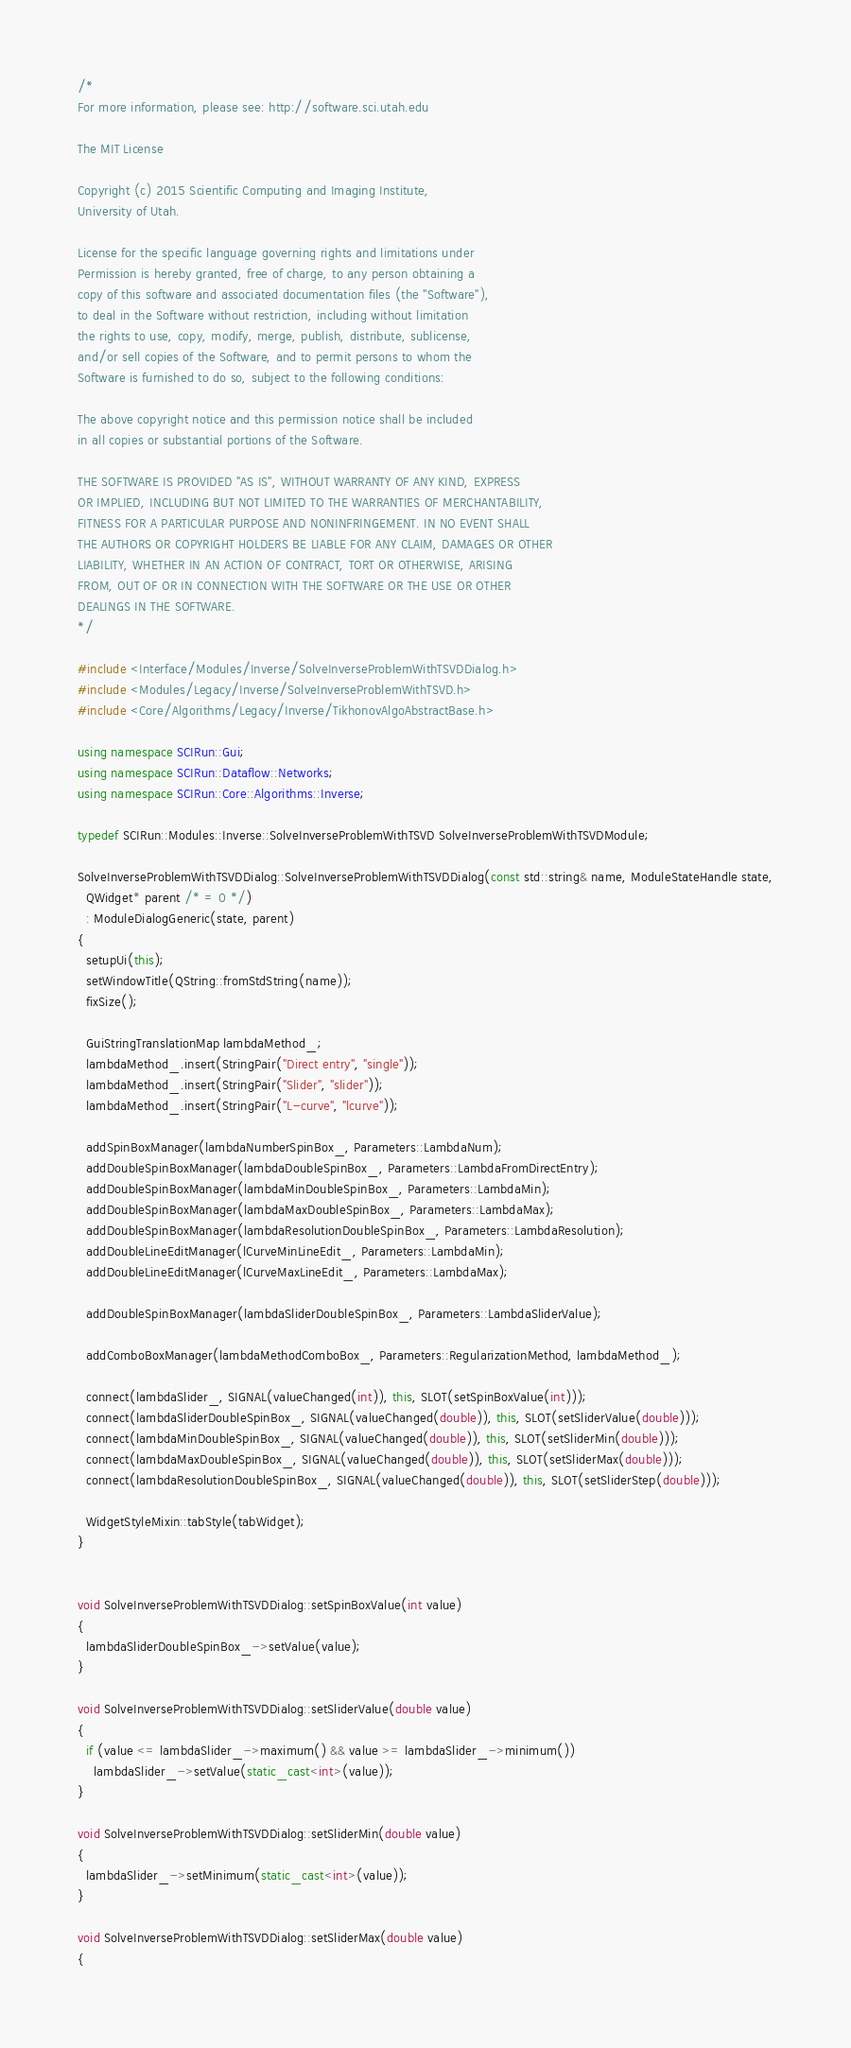<code> <loc_0><loc_0><loc_500><loc_500><_C++_>/*
For more information, please see: http://software.sci.utah.edu

The MIT License

Copyright (c) 2015 Scientific Computing and Imaging Institute,
University of Utah.

License for the specific language governing rights and limitations under
Permission is hereby granted, free of charge, to any person obtaining a
copy of this software and associated documentation files (the "Software"),
to deal in the Software without restriction, including without limitation
the rights to use, copy, modify, merge, publish, distribute, sublicense,
and/or sell copies of the Software, and to permit persons to whom the
Software is furnished to do so, subject to the following conditions:

The above copyright notice and this permission notice shall be included
in all copies or substantial portions of the Software.

THE SOFTWARE IS PROVIDED "AS IS", WITHOUT WARRANTY OF ANY KIND, EXPRESS
OR IMPLIED, INCLUDING BUT NOT LIMITED TO THE WARRANTIES OF MERCHANTABILITY,
FITNESS FOR A PARTICULAR PURPOSE AND NONINFRINGEMENT. IN NO EVENT SHALL
THE AUTHORS OR COPYRIGHT HOLDERS BE LIABLE FOR ANY CLAIM, DAMAGES OR OTHER
LIABILITY, WHETHER IN AN ACTION OF CONTRACT, TORT OR OTHERWISE, ARISING
FROM, OUT OF OR IN CONNECTION WITH THE SOFTWARE OR THE USE OR OTHER
DEALINGS IN THE SOFTWARE.
*/

#include <Interface/Modules/Inverse/SolveInverseProblemWithTSVDDialog.h>
#include <Modules/Legacy/Inverse/SolveInverseProblemWithTSVD.h>
#include <Core/Algorithms/Legacy/Inverse/TikhonovAlgoAbstractBase.h>

using namespace SCIRun::Gui;
using namespace SCIRun::Dataflow::Networks;
using namespace SCIRun::Core::Algorithms::Inverse;

typedef SCIRun::Modules::Inverse::SolveInverseProblemWithTSVD SolveInverseProblemWithTSVDModule;

SolveInverseProblemWithTSVDDialog::SolveInverseProblemWithTSVDDialog(const std::string& name, ModuleStateHandle state,
  QWidget* parent /* = 0 */)
  : ModuleDialogGeneric(state, parent)
{
  setupUi(this);
  setWindowTitle(QString::fromStdString(name));
  fixSize();

  GuiStringTranslationMap lambdaMethod_;
  lambdaMethod_.insert(StringPair("Direct entry", "single"));
  lambdaMethod_.insert(StringPair("Slider", "slider"));
  lambdaMethod_.insert(StringPair("L-curve", "lcurve"));

  addSpinBoxManager(lambdaNumberSpinBox_, Parameters::LambdaNum);
  addDoubleSpinBoxManager(lambdaDoubleSpinBox_, Parameters::LambdaFromDirectEntry);
  addDoubleSpinBoxManager(lambdaMinDoubleSpinBox_, Parameters::LambdaMin);
  addDoubleSpinBoxManager(lambdaMaxDoubleSpinBox_, Parameters::LambdaMax);
  addDoubleSpinBoxManager(lambdaResolutionDoubleSpinBox_, Parameters::LambdaResolution);
  addDoubleLineEditManager(lCurveMinLineEdit_, Parameters::LambdaMin);
  addDoubleLineEditManager(lCurveMaxLineEdit_, Parameters::LambdaMax);

  addDoubleSpinBoxManager(lambdaSliderDoubleSpinBox_, Parameters::LambdaSliderValue);

  addComboBoxManager(lambdaMethodComboBox_, Parameters::RegularizationMethod, lambdaMethod_);

  connect(lambdaSlider_, SIGNAL(valueChanged(int)), this, SLOT(setSpinBoxValue(int)));
  connect(lambdaSliderDoubleSpinBox_, SIGNAL(valueChanged(double)), this, SLOT(setSliderValue(double)));
  connect(lambdaMinDoubleSpinBox_, SIGNAL(valueChanged(double)), this, SLOT(setSliderMin(double)));
  connect(lambdaMaxDoubleSpinBox_, SIGNAL(valueChanged(double)), this, SLOT(setSliderMax(double)));
  connect(lambdaResolutionDoubleSpinBox_, SIGNAL(valueChanged(double)), this, SLOT(setSliderStep(double)));

  WidgetStyleMixin::tabStyle(tabWidget);
}


void SolveInverseProblemWithTSVDDialog::setSpinBoxValue(int value)
{
  lambdaSliderDoubleSpinBox_->setValue(value);
}

void SolveInverseProblemWithTSVDDialog::setSliderValue(double value)
{
  if (value <= lambdaSlider_->maximum() && value >= lambdaSlider_->minimum())
    lambdaSlider_->setValue(static_cast<int>(value));
}

void SolveInverseProblemWithTSVDDialog::setSliderMin(double value)
{
  lambdaSlider_->setMinimum(static_cast<int>(value));
}

void SolveInverseProblemWithTSVDDialog::setSliderMax(double value)
{</code> 